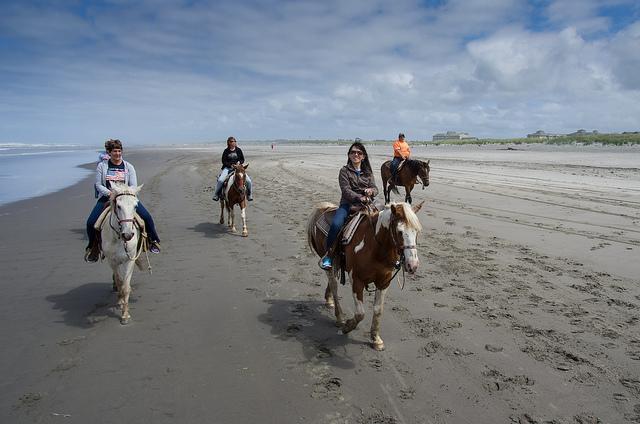How many animals are shown?
Give a very brief answer. 4. How many people are visible?
Give a very brief answer. 2. How many horses are in the picture?
Give a very brief answer. 2. How many rolls of toilet paper are there?
Give a very brief answer. 0. 